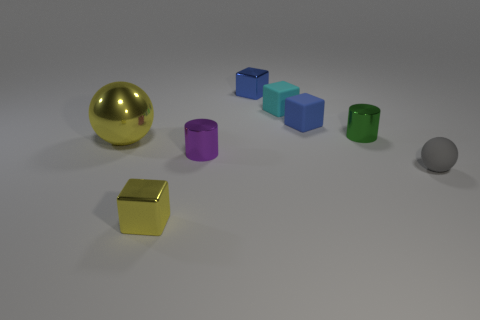Subtract all blue blocks. How many were subtracted if there are1blue blocks left? 1 Subtract all yellow metallic blocks. How many blocks are left? 3 Add 2 large gray shiny cubes. How many objects exist? 10 Subtract all green cylinders. How many cylinders are left? 1 Subtract all cylinders. How many objects are left? 6 Subtract 2 balls. How many balls are left? 0 Add 6 spheres. How many spheres exist? 8 Subtract 0 gray cylinders. How many objects are left? 8 Subtract all yellow spheres. Subtract all yellow cylinders. How many spheres are left? 1 Subtract all blue cubes. How many purple balls are left? 0 